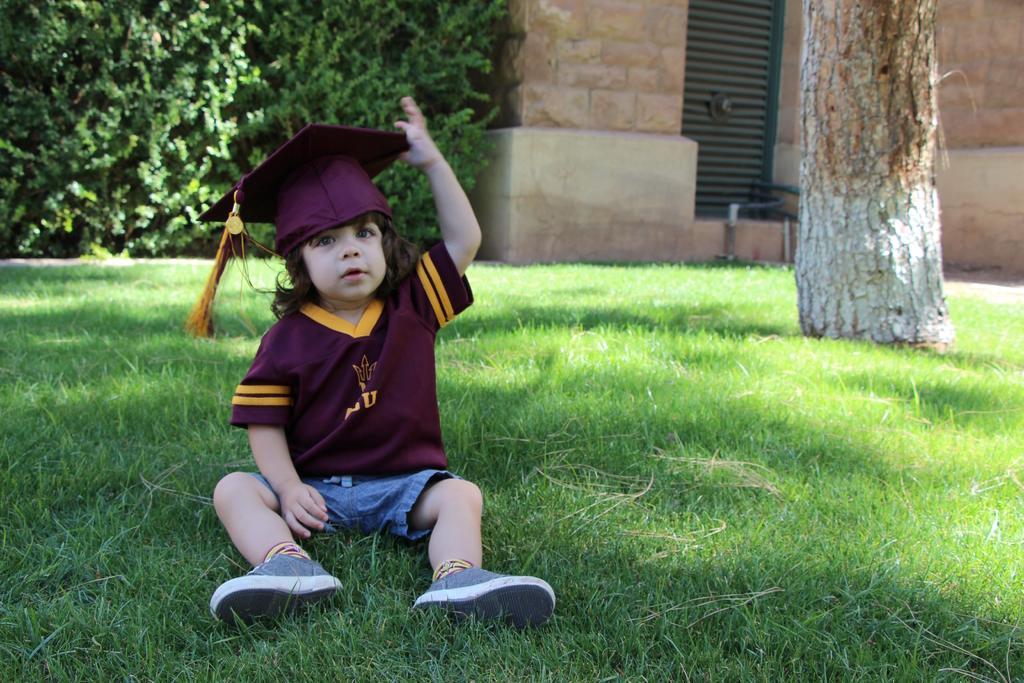Please provide a concise description of this image. In this image we can see there is a boy, branch and grass. The boy wore a hat. In the background we can see a wall, grille and plants.  